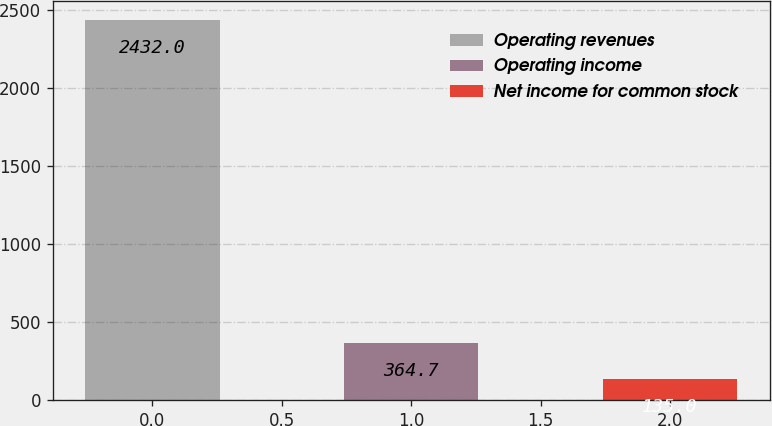Convert chart to OTSL. <chart><loc_0><loc_0><loc_500><loc_500><bar_chart><fcel>Operating revenues<fcel>Operating income<fcel>Net income for common stock<nl><fcel>2432<fcel>364.7<fcel>135<nl></chart> 